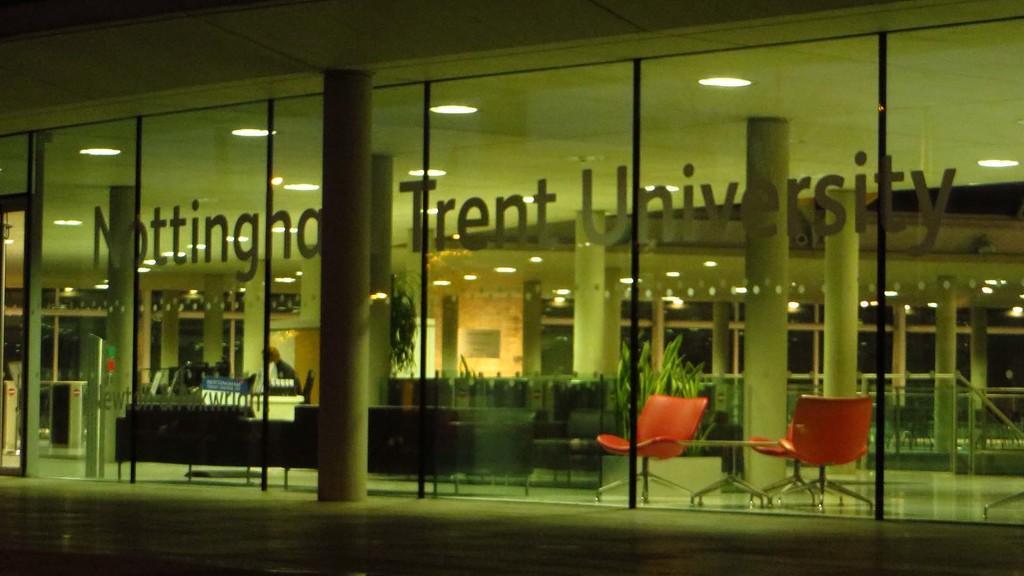How would you summarize this image in a sentence or two? There is a building with glass wall and pillars. On the glass wall something is written. Inside the building there are sofas, chairs and plants. On the ceiling there are lights. 